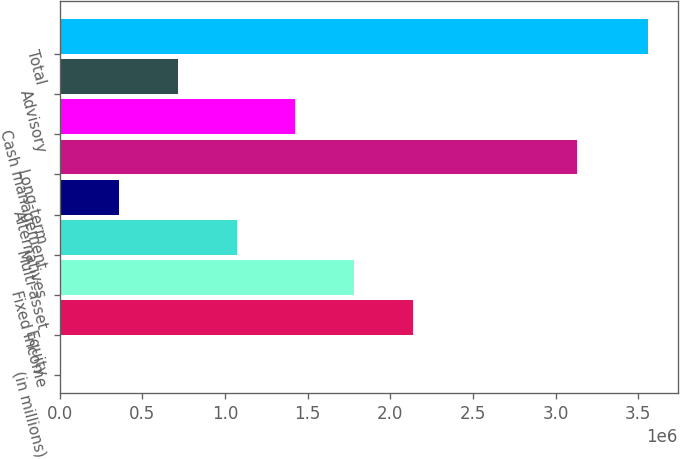<chart> <loc_0><loc_0><loc_500><loc_500><bar_chart><fcel>(in millions)<fcel>Equity<fcel>Fixed income<fcel>Multi-asset<fcel>Alternatives<fcel>Long-term<fcel>Cash management<fcel>Advisory<fcel>Total<nl><fcel>2010<fcel>2.13738e+06<fcel>1.78149e+06<fcel>1.0697e+06<fcel>357906<fcel>3.13112e+06<fcel>1.42559e+06<fcel>713802<fcel>3.56097e+06<nl></chart> 